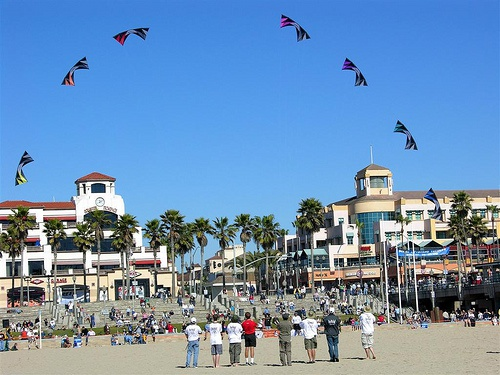Describe the objects in this image and their specific colors. I can see people in gray, darkgray, black, and lightgray tones, people in gray, white, darkgray, and tan tones, people in gray, black, blue, and darkblue tones, people in gray, white, black, and darkgray tones, and people in gray, black, and darkgray tones in this image. 